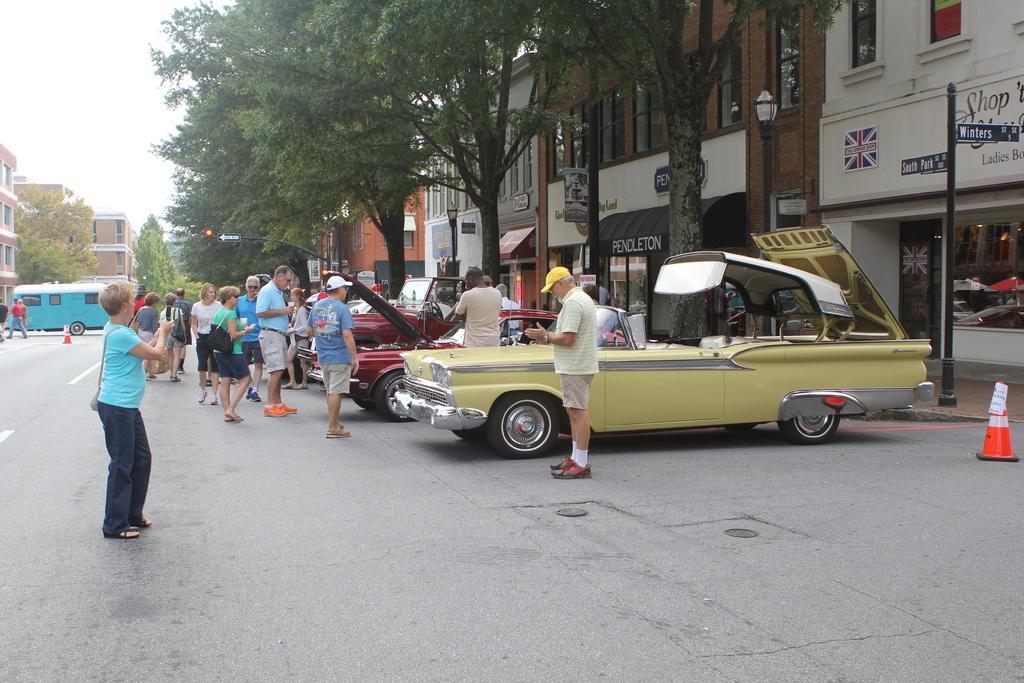How would you summarize this image in a sentence or two? These are the cars, which are parked. I can see groups of people standing and few people walking. These are the buildings with the glass doors. I can see the trees. On the right side of the image, I can see a cone barrier, which is placed on the road. These are the address boards, which are attached to the poles This is the sky. 